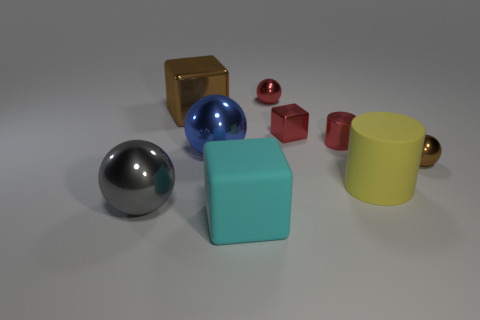Besides the shapes, is there anything suggesting this scene is indoors or outdoors? Based on the controlled lighting and the lack of any natural elements like plants or sky, the scene appears to be set indoors, possibly in a studio environment where the lighting and background can be managed to enhance the objects' appearance. 